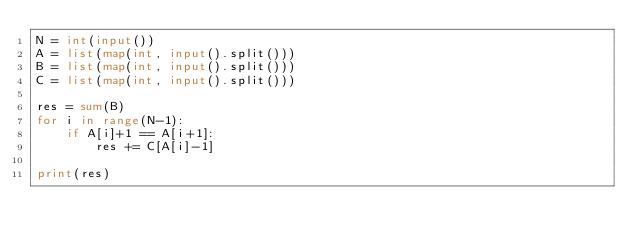<code> <loc_0><loc_0><loc_500><loc_500><_Python_>N = int(input())
A = list(map(int, input().split()))
B = list(map(int, input().split()))
C = list(map(int, input().split()))

res = sum(B)
for i in range(N-1):
    if A[i]+1 == A[i+1]:
        res += C[A[i]-1]

print(res)</code> 